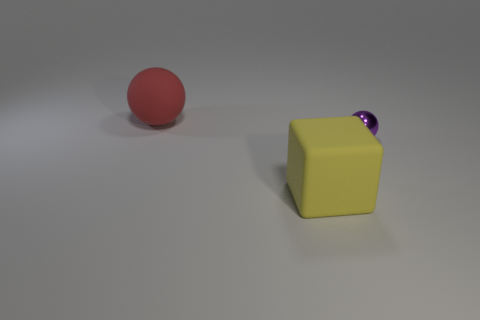There is a object that is on the left side of the big yellow rubber cube; what is its size?
Keep it short and to the point. Large. How many yellow objects are metal spheres or big spheres?
Keep it short and to the point. 0. Is there any other thing that has the same material as the large red ball?
Your answer should be very brief. Yes. What is the material of the purple object that is the same shape as the red matte thing?
Your answer should be very brief. Metal. Are there an equal number of big yellow objects behind the small ball and yellow matte things?
Your answer should be compact. No. There is a object that is both to the left of the purple metallic object and behind the large cube; how big is it?
Keep it short and to the point. Large. Are there any other things of the same color as the small metallic object?
Give a very brief answer. No. There is a ball right of the large object behind the yellow matte object; what is its size?
Your response must be concise. Small. What is the color of the thing that is both left of the tiny purple metallic sphere and behind the rubber cube?
Provide a succinct answer. Red. What number of other objects are there of the same size as the yellow matte object?
Ensure brevity in your answer.  1. 